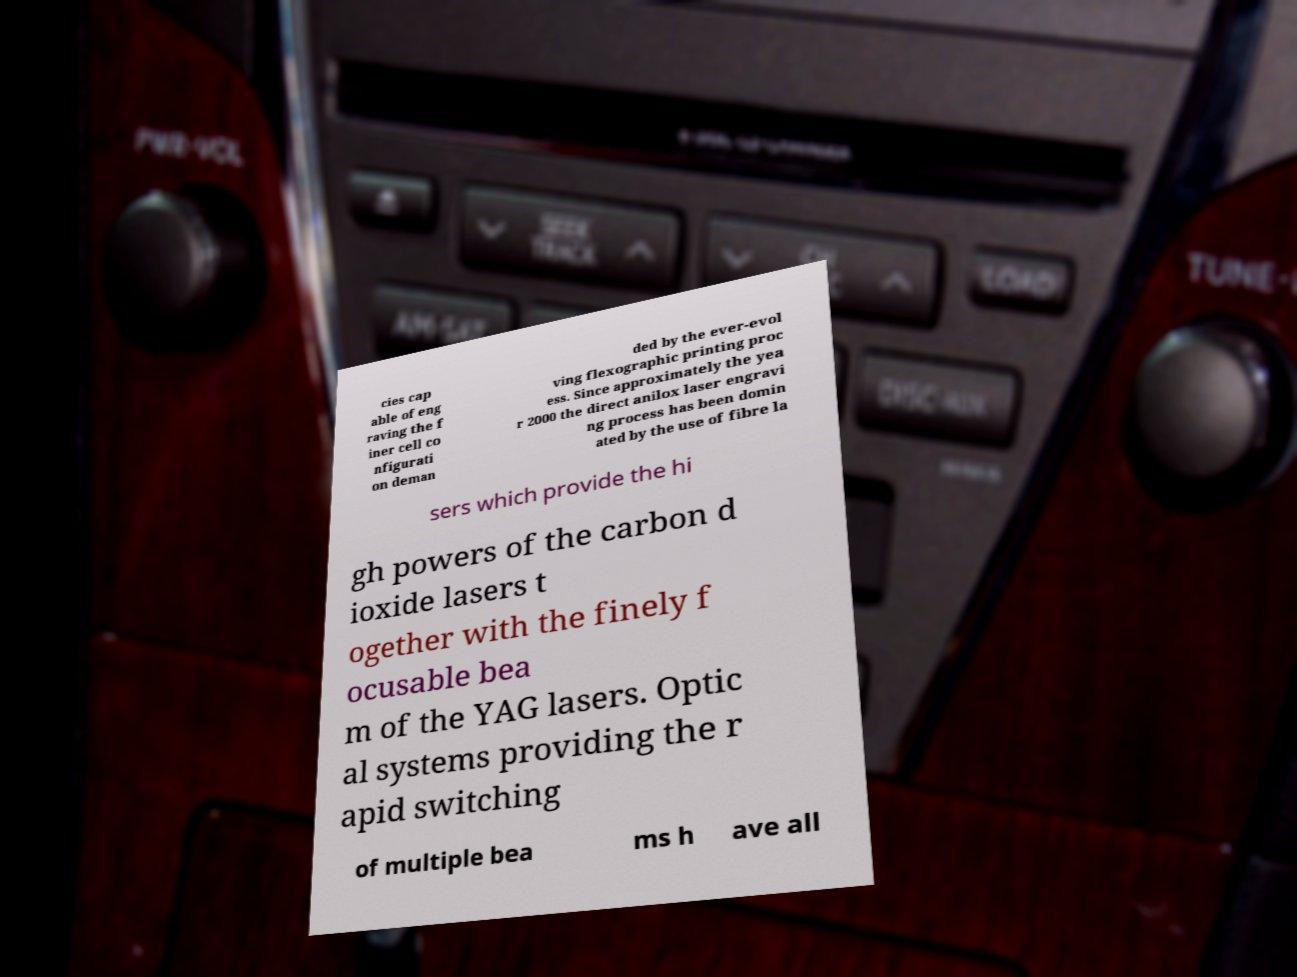Could you extract and type out the text from this image? cies cap able of eng raving the f iner cell co nfigurati on deman ded by the ever-evol ving flexographic printing proc ess. Since approximately the yea r 2000 the direct anilox laser engravi ng process has been domin ated by the use of fibre la sers which provide the hi gh powers of the carbon d ioxide lasers t ogether with the finely f ocusable bea m of the YAG lasers. Optic al systems providing the r apid switching of multiple bea ms h ave all 